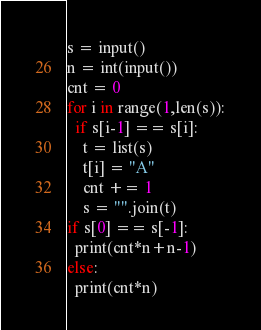Convert code to text. <code><loc_0><loc_0><loc_500><loc_500><_Python_>s = input()
n = int(input())
cnt = 0
for i in range(1,len(s)):
  if s[i-1] == s[i]:
    t = list(s)
    t[i] = "A"
    cnt += 1
    s = "".join(t)
if s[0] == s[-1]:
  print(cnt*n+n-1)
else:
  print(cnt*n)</code> 